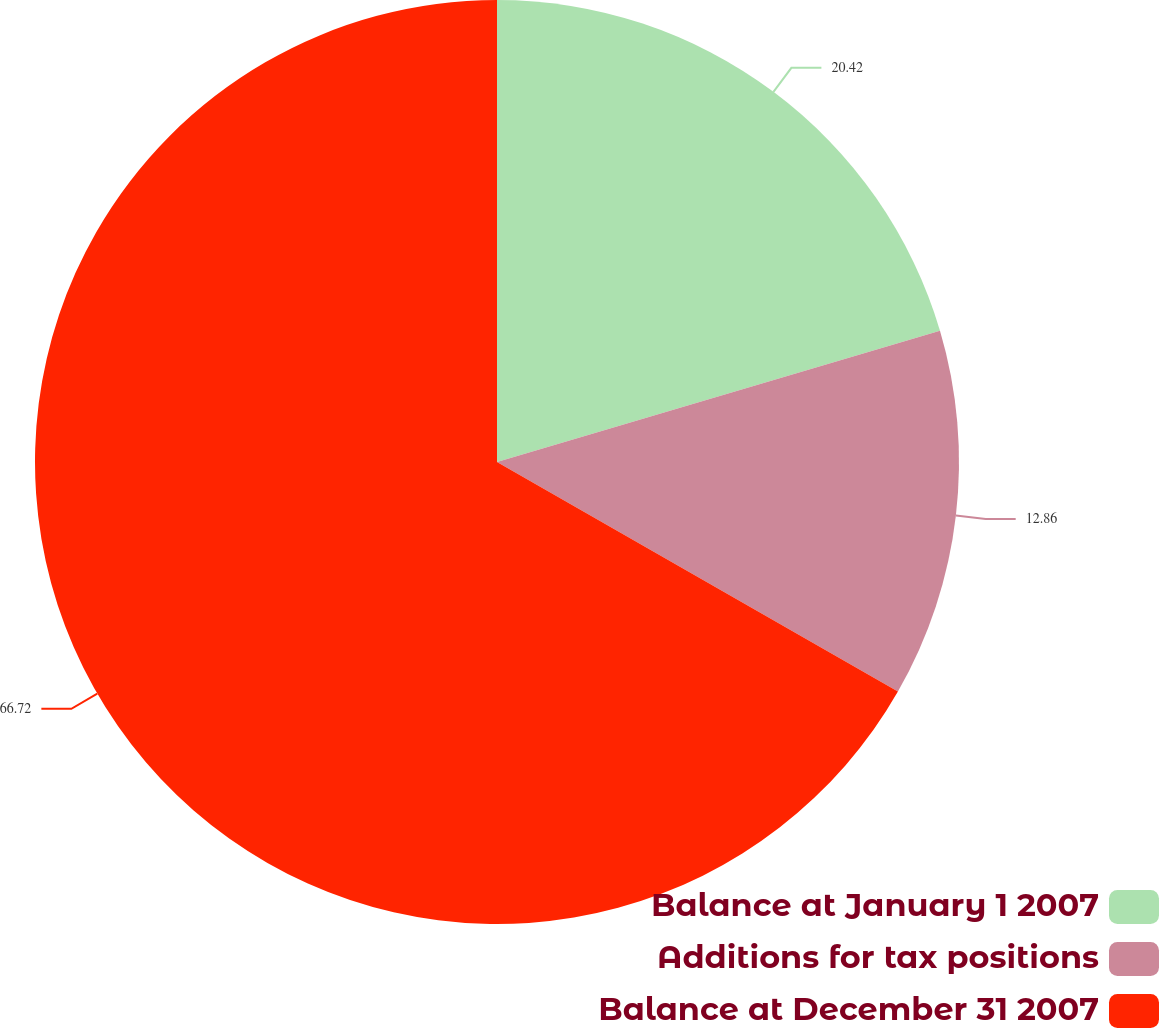Convert chart to OTSL. <chart><loc_0><loc_0><loc_500><loc_500><pie_chart><fcel>Balance at January 1 2007<fcel>Additions for tax positions<fcel>Balance at December 31 2007<nl><fcel>20.42%<fcel>12.86%<fcel>66.73%<nl></chart> 